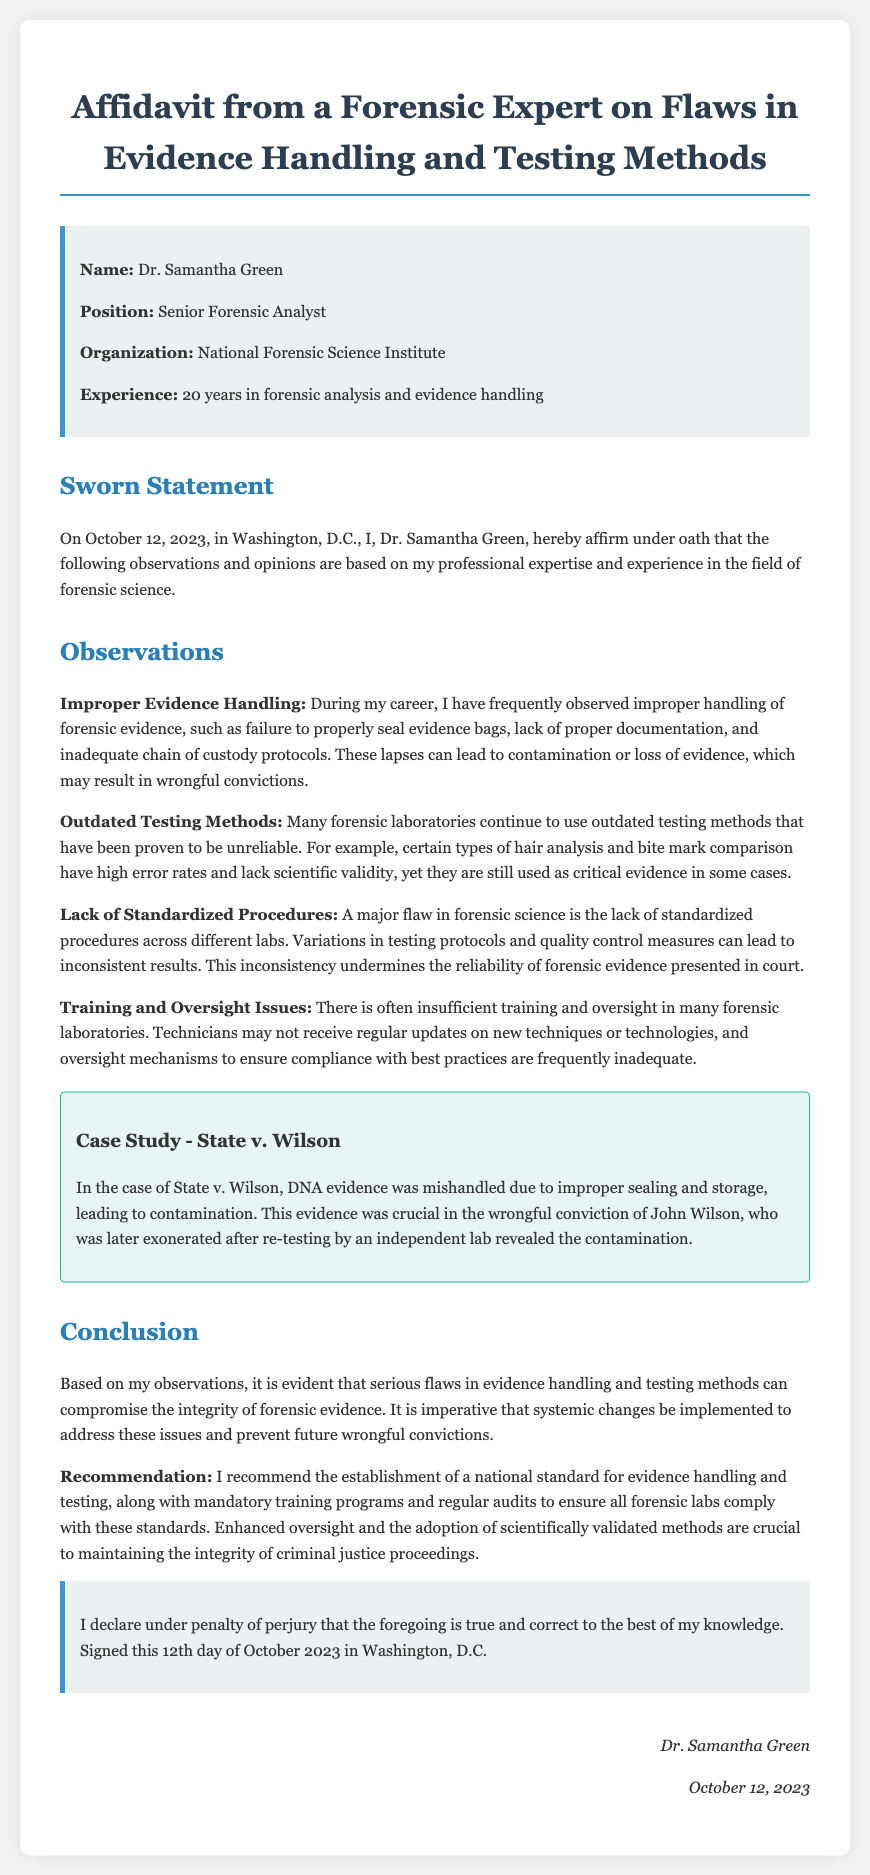What is the name of the forensic expert? The name of the forensic expert is mentioned in the highlighted section, which includes the name Dr. Samantha Green.
Answer: Dr. Samantha Green What position does Dr. Samantha Green hold? Dr. Samantha Green's position is stated in the highlighted section where it says "Senior Forensic Analyst."
Answer: Senior Forensic Analyst When was the affidavit sworn? The document provides the date of the sworn statement in the initial paragraph, stating it was on October 12, 2023.
Answer: October 12, 2023 What is one major issue identified in evidence handling? The affidavit points out "Improper Evidence Handling" as a significant issue, including examples like failure to properly seal evidence bags.
Answer: Improper Evidence Handling What is the specific case mentioned in a case study? The case study presents "State v. Wilson" where DNA evidence was mishandled.
Answer: State v. Wilson What does Dr. Green recommend for forensic labs? Dr. Green recommends the establishment of a national standard for evidence handling and testing as part of her conclusions in the affidavit.
Answer: National standard for evidence handling and testing How many years of experience does Dr. Green have? Dr. Green's experience is highlighted as being 20 years in the field of forensic analysis and evidence handling.
Answer: 20 years What is a flaw mentioned regarding testing methods? One major flaw discussed in the document is "Outdated Testing Methods," which highlights reliability issues with certain forensic techniques.
Answer: Outdated Testing Methods What is the primary conclusion of Dr. Green's statement? The conclusion indicates serious flaws in evidence handling and testing methods threaten the integrity of forensic evidence.
Answer: Flaws in evidence handling and testing methods 